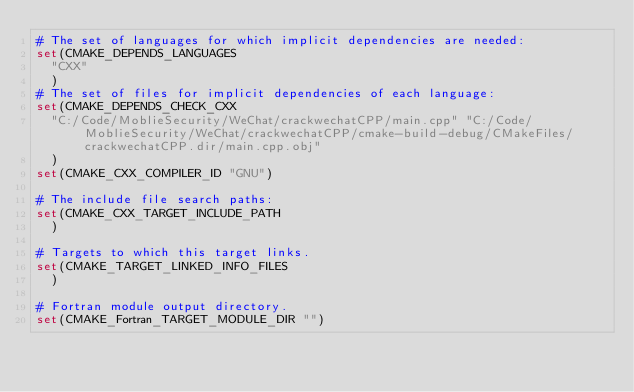<code> <loc_0><loc_0><loc_500><loc_500><_CMake_># The set of languages for which implicit dependencies are needed:
set(CMAKE_DEPENDS_LANGUAGES
  "CXX"
  )
# The set of files for implicit dependencies of each language:
set(CMAKE_DEPENDS_CHECK_CXX
  "C:/Code/MoblieSecurity/WeChat/crackwechatCPP/main.cpp" "C:/Code/MoblieSecurity/WeChat/crackwechatCPP/cmake-build-debug/CMakeFiles/crackwechatCPP.dir/main.cpp.obj"
  )
set(CMAKE_CXX_COMPILER_ID "GNU")

# The include file search paths:
set(CMAKE_CXX_TARGET_INCLUDE_PATH
  )

# Targets to which this target links.
set(CMAKE_TARGET_LINKED_INFO_FILES
  )

# Fortran module output directory.
set(CMAKE_Fortran_TARGET_MODULE_DIR "")
</code> 